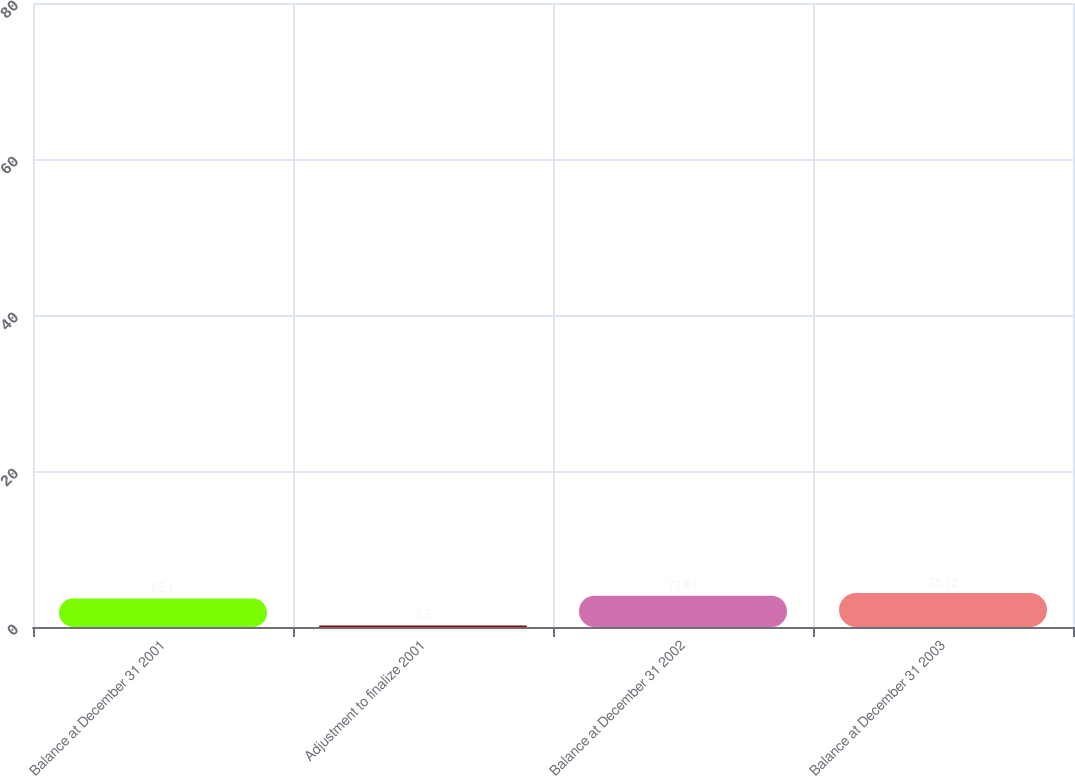<chart> <loc_0><loc_0><loc_500><loc_500><bar_chart><fcel>Balance at December 31 2001<fcel>Adjustment to finalize 2001<fcel>Balance at December 31 2002<fcel>Balance at December 31 2003<nl><fcel>65.1<fcel>3.5<fcel>71.61<fcel>78.12<nl></chart> 